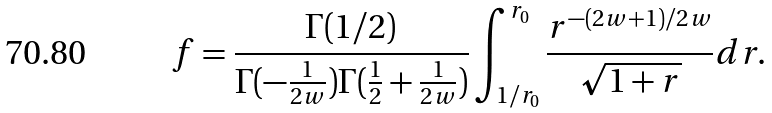<formula> <loc_0><loc_0><loc_500><loc_500>f = \frac { \Gamma ( 1 / 2 ) } { \Gamma ( - \frac { 1 } { 2 w } ) \Gamma ( \frac { 1 } { 2 } + \frac { 1 } { 2 w } ) } \int _ { 1 / r _ { 0 } } ^ { r _ { 0 } } \frac { r ^ { - ( 2 w + 1 ) / 2 w } } { \sqrt { 1 + r } } d r .</formula> 